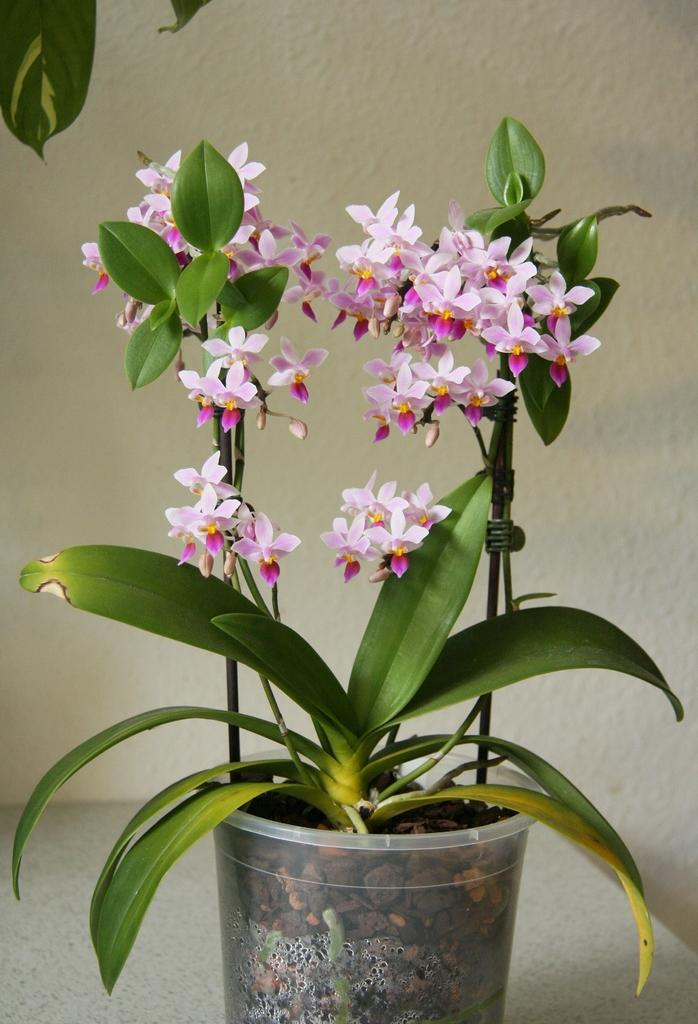What type of plant can be seen in the image? There is a plant with flowers in the image. How is the plant situated in the image? The plant is in a container. What can be seen below the plant in the image? The ground is visible in the image. What is present in the background of the image? There is a wall in the image. What type of learning is taking place in the image? There is no indication of learning or any educational activity in the image. 